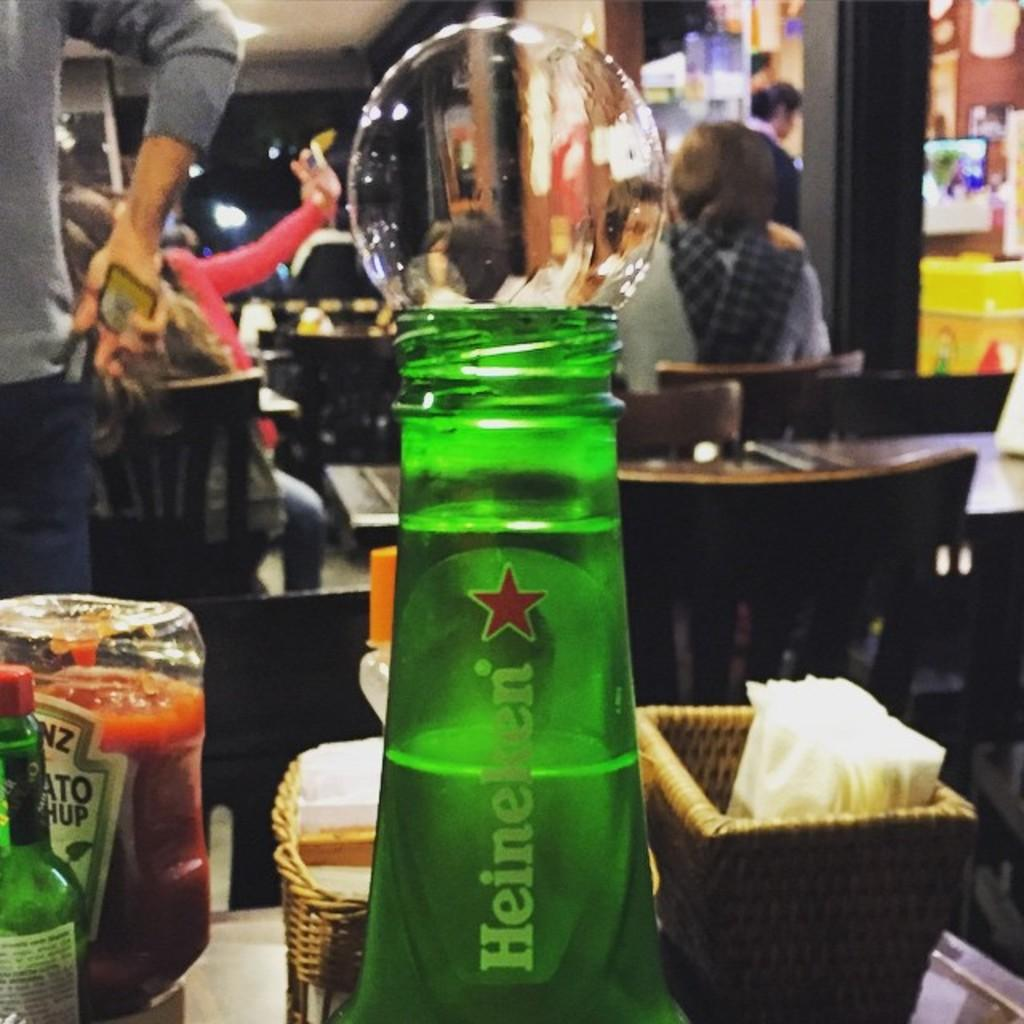What objects are on the table in the image? There are bottles, a bubble, and baskets with tissue on the table. What is the person in the background holding? The person in the background is holding a mobile. What are the people in the background doing? The people in the background are sitting on chairs. Can you describe the objects on the table? The table has bottles, a bubble, and baskets with tissue. How does the person in the background perform the division of the objects on the table? There is no division of objects being performed in the image, and the person in the background is not interacting with the table. 